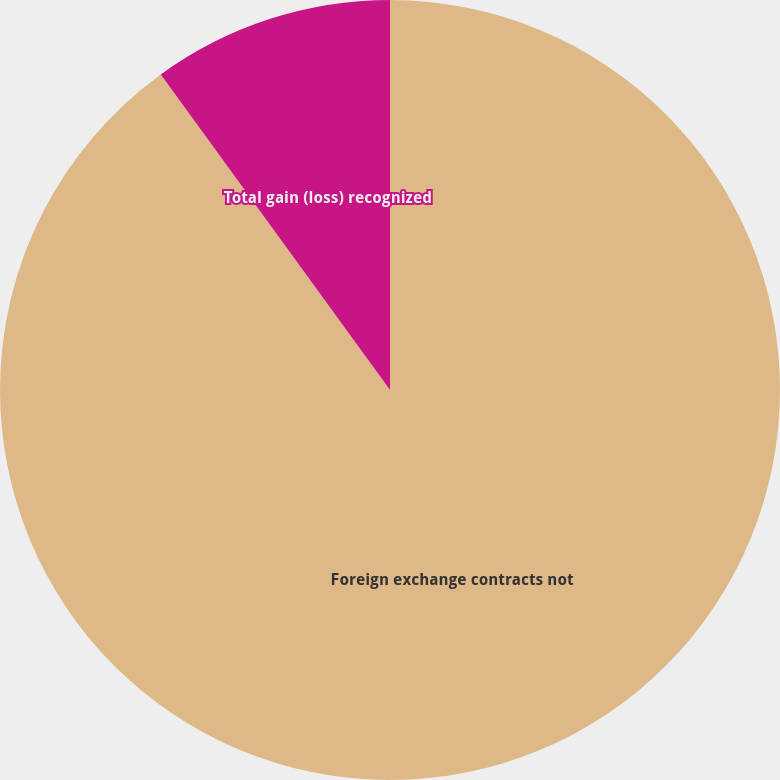Convert chart to OTSL. <chart><loc_0><loc_0><loc_500><loc_500><pie_chart><fcel>Foreign exchange contracts not<fcel>Total gain (loss) recognized<nl><fcel>90.0%<fcel>10.0%<nl></chart> 